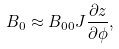Convert formula to latex. <formula><loc_0><loc_0><loc_500><loc_500>B _ { 0 } \approx B _ { 0 0 } J \frac { \partial z } { \partial \phi } ,</formula> 